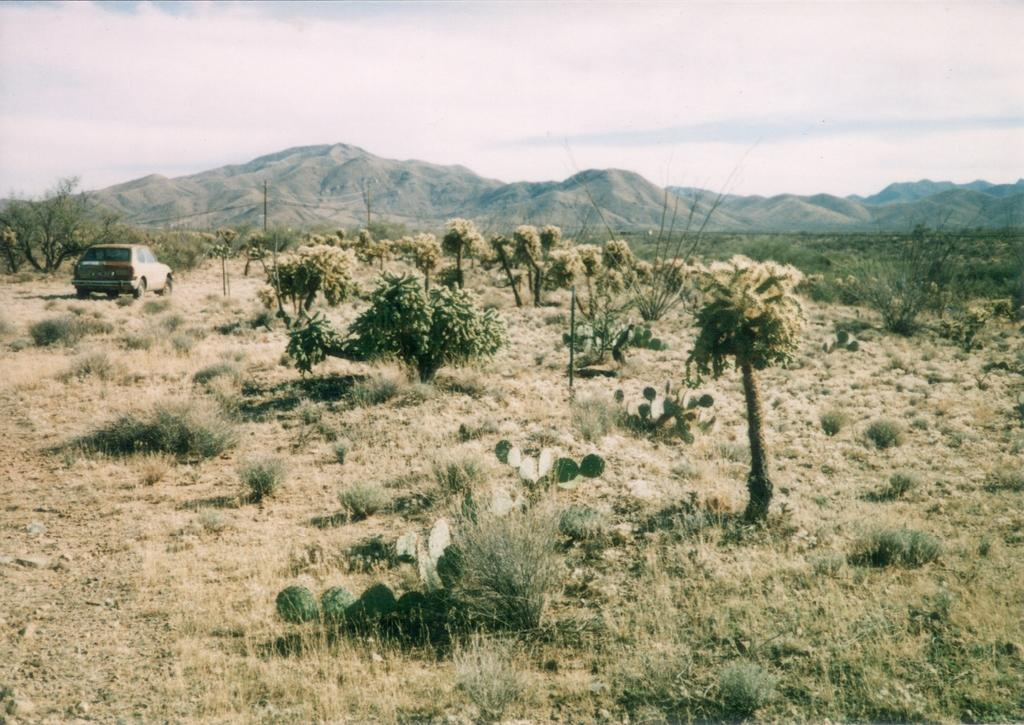What is the main subject of the image? There is a car in the image. What type of vegetation can be seen in the image? There are trees and cactus plants visible in the image. What is the ground like in the image? The ground is visible in the image. What can be seen in the background of the image? There are hills in the background of the image. What does the father say in the image? There is no father present in the image, so it is not possible to answer that question. 